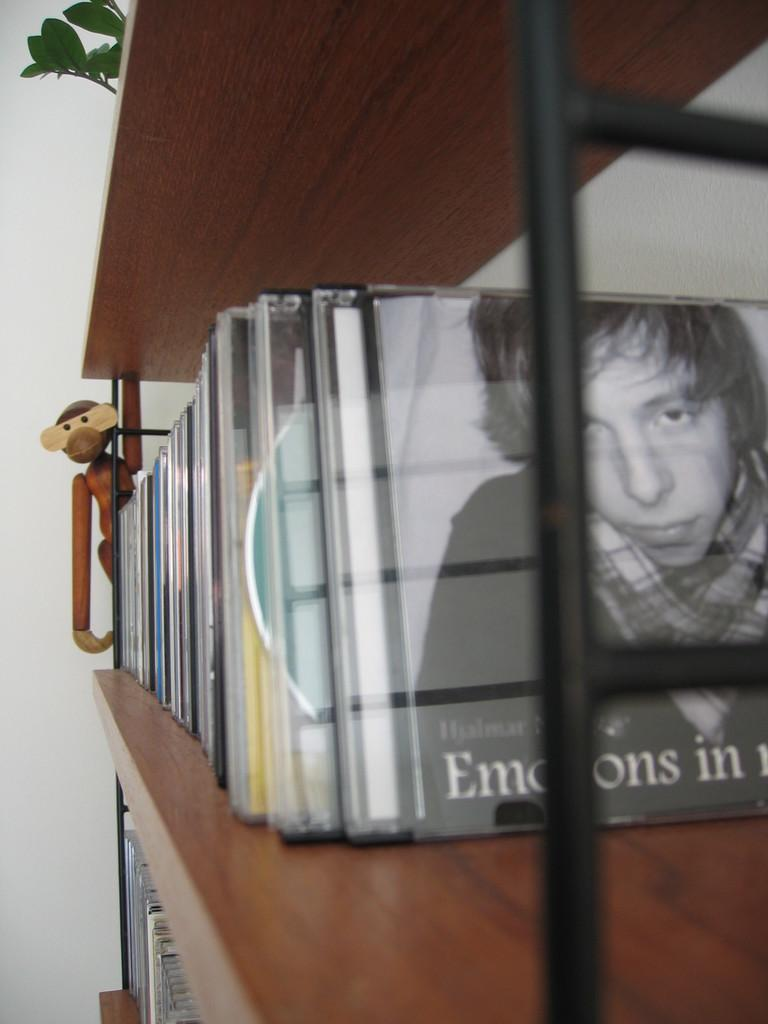What type of items can be seen in the image? There are many DVD cases in the image. How are the DVD cases arranged in the image? The DVD cases are arranged on a wooden shelf. What material is the shelf made of? The shelf is made of wood. Can you describe the arrangement of the DVD cases on the shelf? The DVD cases are arranged neatly on the wooden shelf. What type of dock can be seen in the image? There is no dock present in the image. 